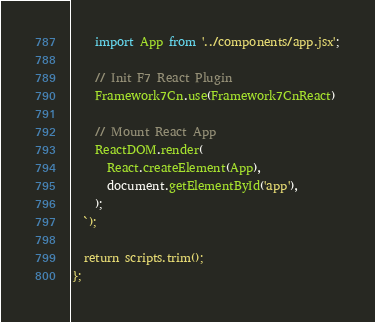<code> <loc_0><loc_0><loc_500><loc_500><_JavaScript_>    import App from '../components/app.jsx';

    // Init F7 React Plugin
    Framework7Cn.use(Framework7CnReact)

    // Mount React App
    ReactDOM.render(
      React.createElement(App),
      document.getElementById('app'),
    );
  `);

  return scripts.trim();
};
</code> 